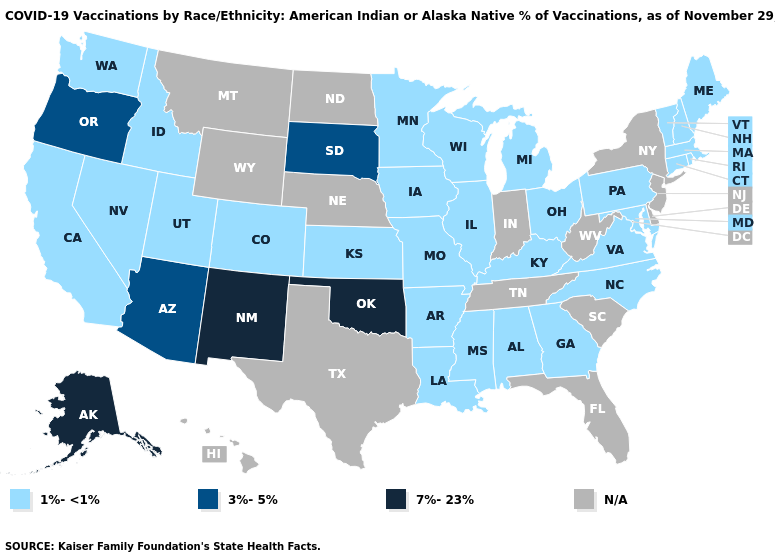Does the map have missing data?
Keep it brief. Yes. What is the value of New Hampshire?
Concise answer only. 1%-<1%. What is the value of Maryland?
Write a very short answer. 1%-<1%. What is the lowest value in states that border Massachusetts?
Concise answer only. 1%-<1%. Which states have the highest value in the USA?
Concise answer only. Alaska, New Mexico, Oklahoma. Does California have the lowest value in the West?
Write a very short answer. Yes. Among the states that border West Virginia , which have the lowest value?
Quick response, please. Kentucky, Maryland, Ohio, Pennsylvania, Virginia. What is the value of Nebraska?
Keep it brief. N/A. Which states hav the highest value in the West?
Answer briefly. Alaska, New Mexico. What is the value of Colorado?
Keep it brief. 1%-<1%. What is the value of Delaware?
Be succinct. N/A. What is the value of Wyoming?
Short answer required. N/A. What is the value of Hawaii?
Short answer required. N/A. What is the lowest value in the USA?
Short answer required. 1%-<1%. What is the highest value in the USA?
Be succinct. 7%-23%. 